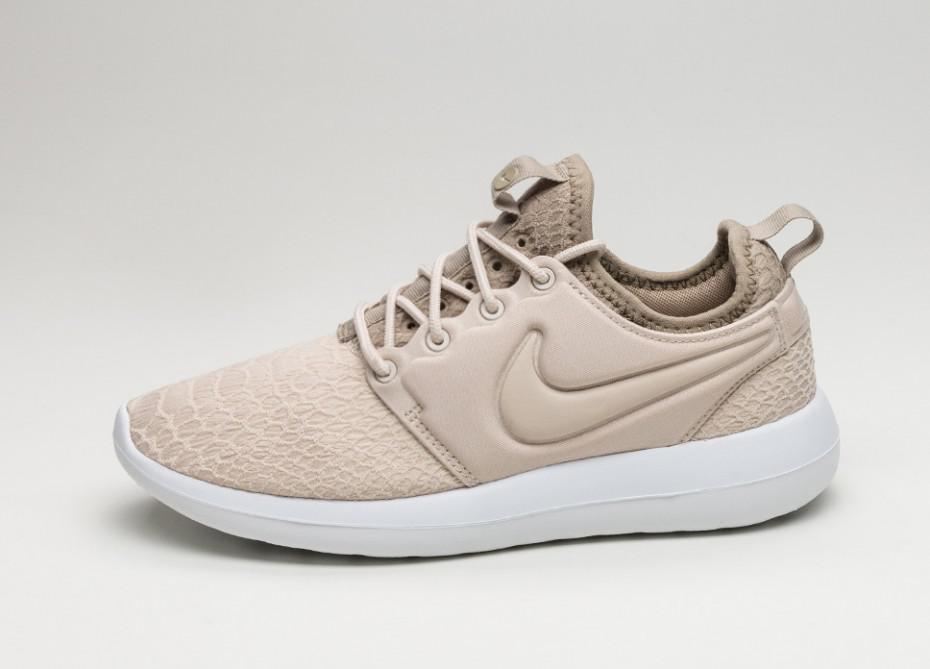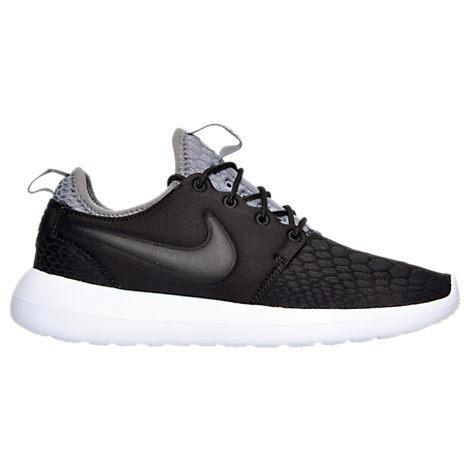The first image is the image on the left, the second image is the image on the right. Given the left and right images, does the statement "The two shoes in the images are facing in opposite directions." hold true? Answer yes or no. Yes. 